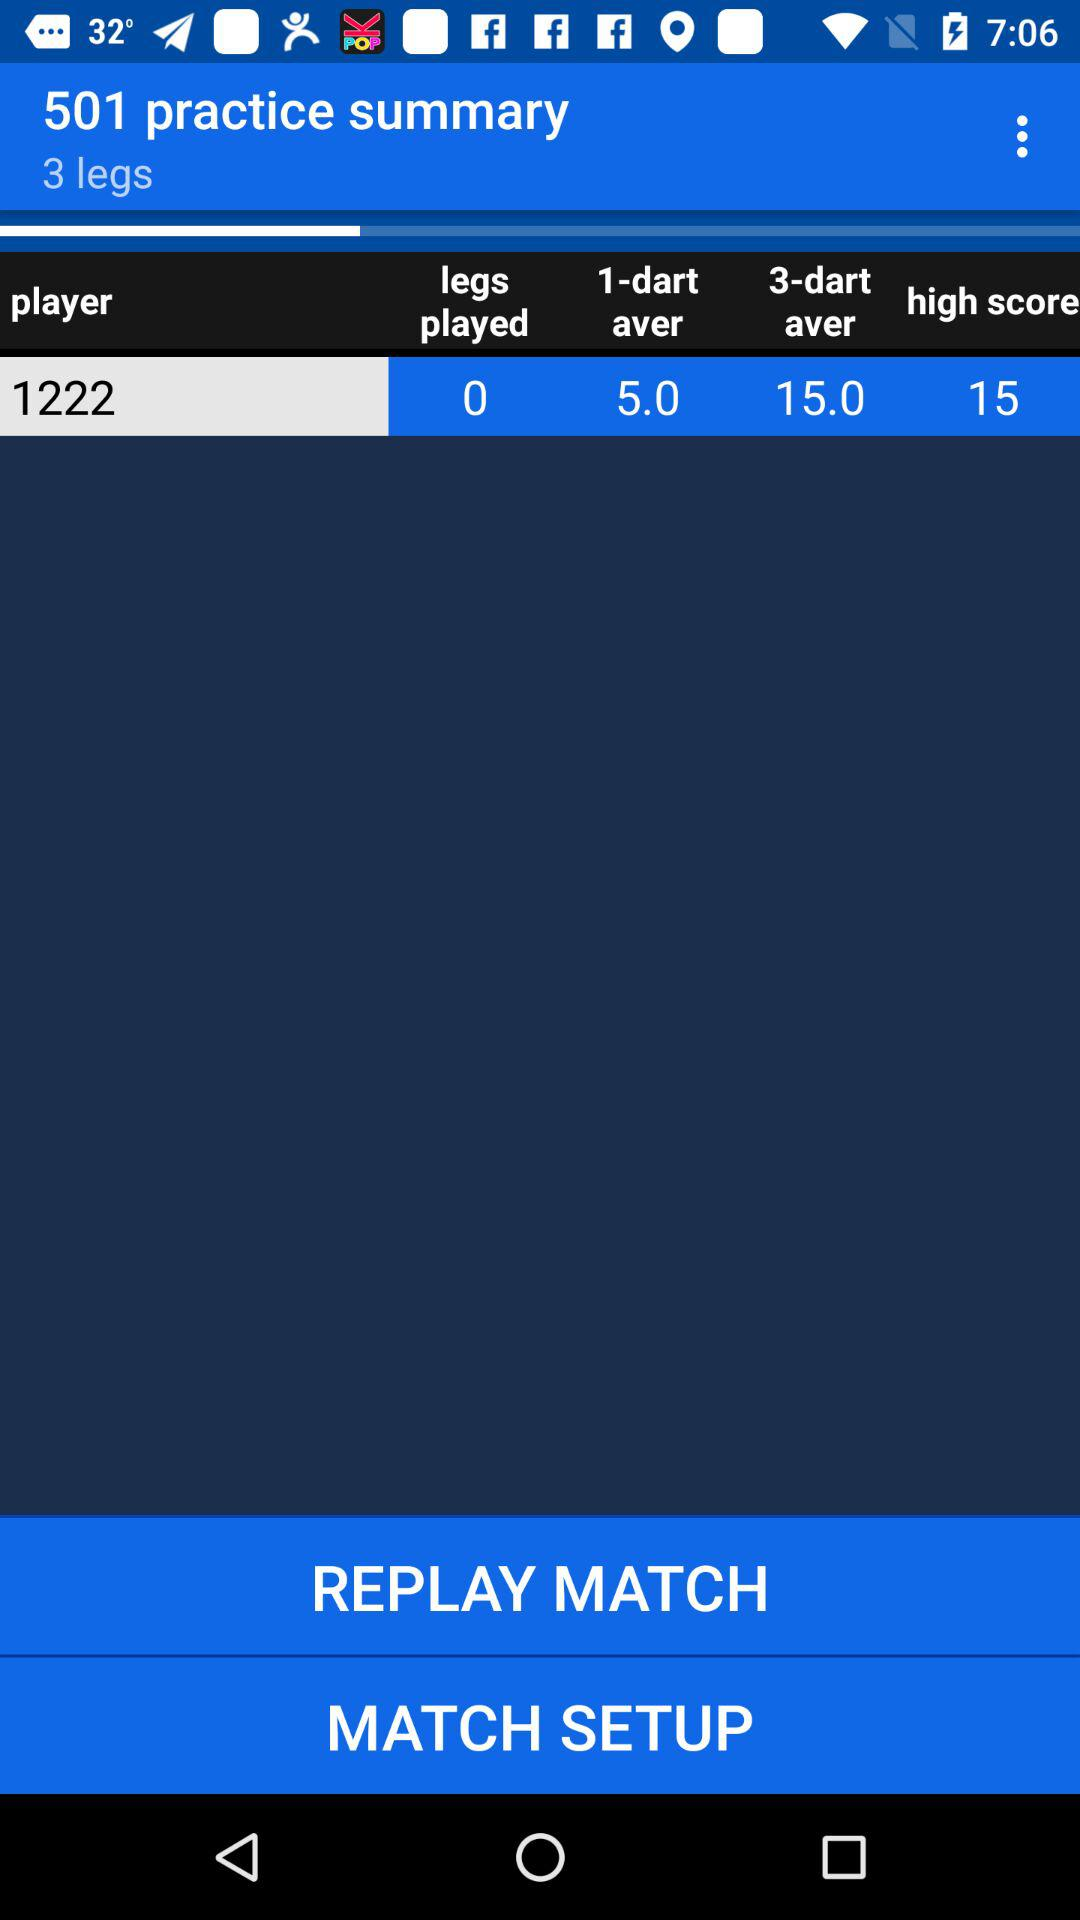What is the difference between the 1-dart average and the 3-dart average?
Answer the question using a single word or phrase. 10.0 